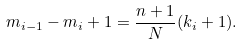Convert formula to latex. <formula><loc_0><loc_0><loc_500><loc_500>m _ { i - 1 } - m _ { i } + 1 = \frac { n + 1 } N ( k _ { i } + 1 ) .</formula> 